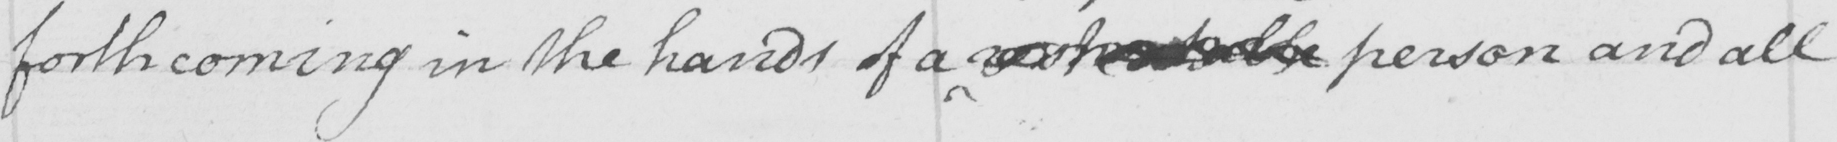What is written in this line of handwriting? forthcoming in the hands of a respectable person and all 